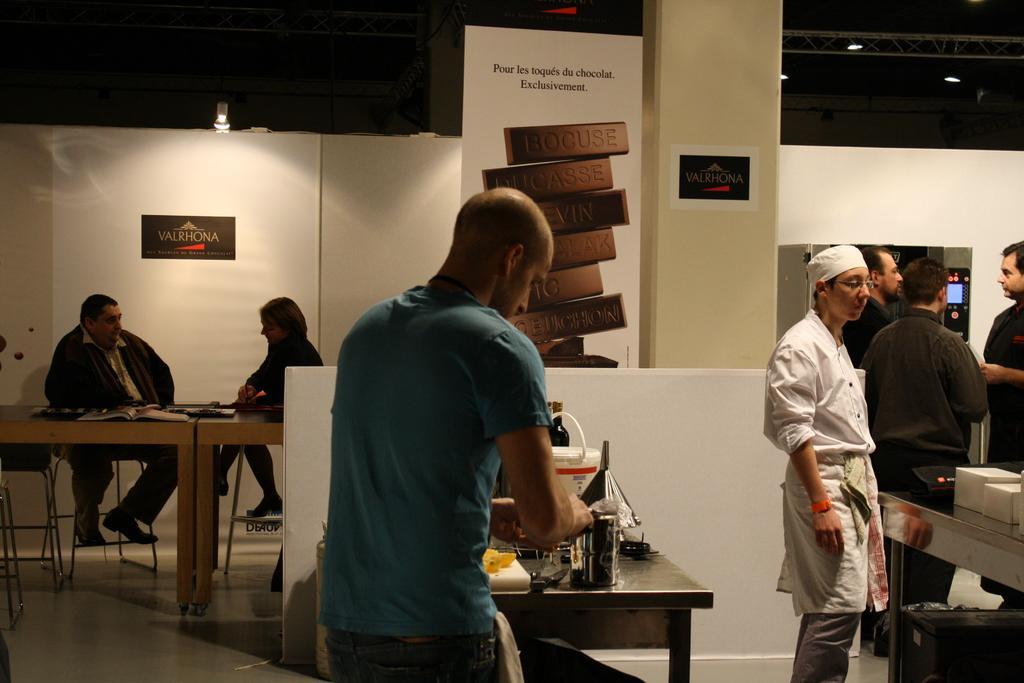Could you give a brief overview of what you see in this image? In this image there are group of peoples. On the left side two people are sitting and having a conversation with each other in their background there is a background with a white colour wall with a name valrhona, in the center the man is standing and is doing some work. At the right side 3 persons with black colour shirt are standing and person with a white colour dress seems like a chef is standing and seeing at the table which is in front of him. In background there is a wall and a banner with a name brocuse. 